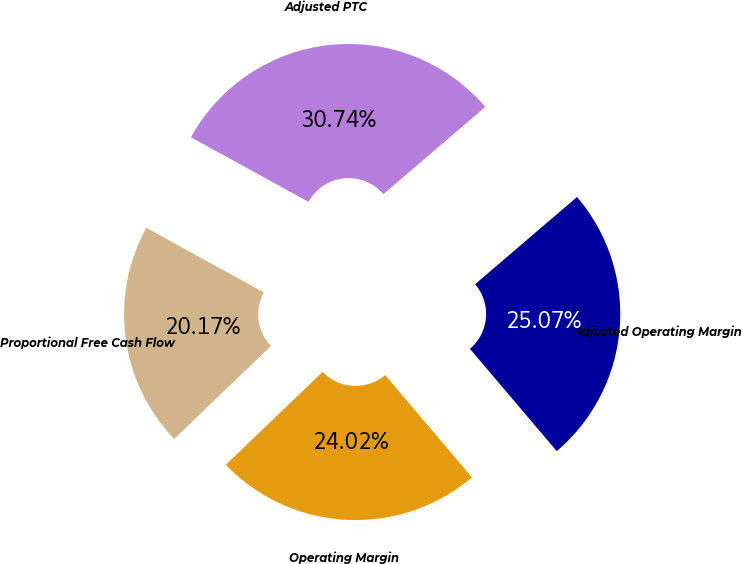Convert chart to OTSL. <chart><loc_0><loc_0><loc_500><loc_500><pie_chart><fcel>Operating Margin<fcel>Adjusted Operating Margin<fcel>Adjusted PTC<fcel>Proportional Free Cash Flow<nl><fcel>24.02%<fcel>25.07%<fcel>30.74%<fcel>20.17%<nl></chart> 